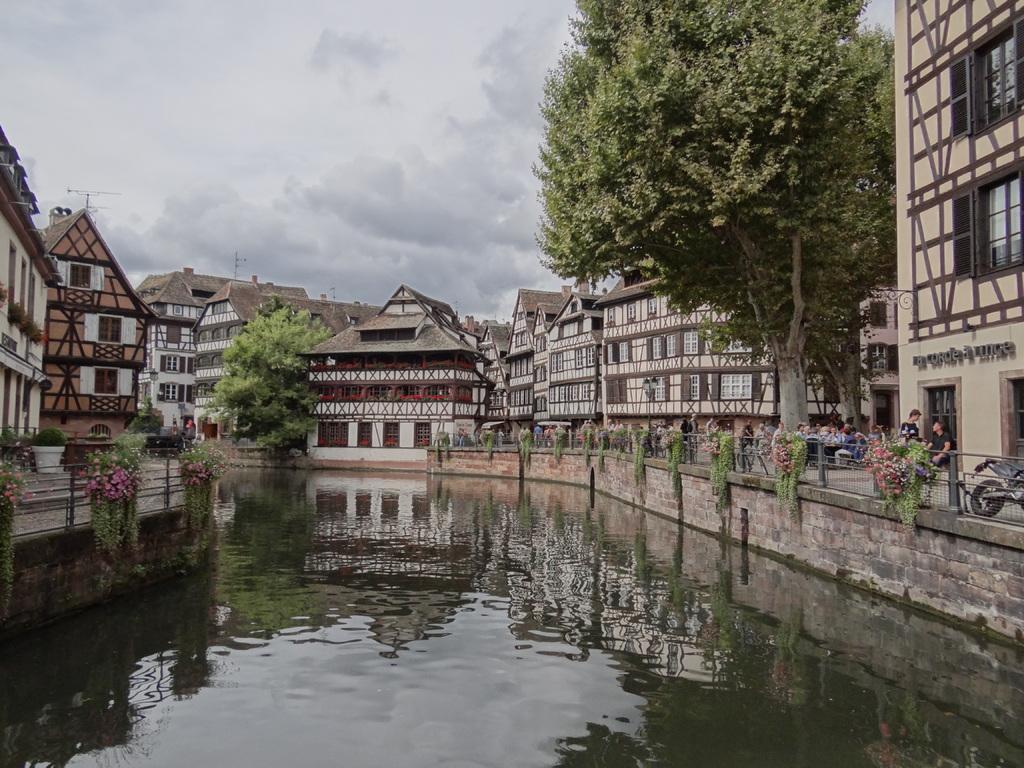In one or two sentences, can you explain what this image depicts? In this picture we can see the lake, around there is a fence, buildings, trees and few people. 